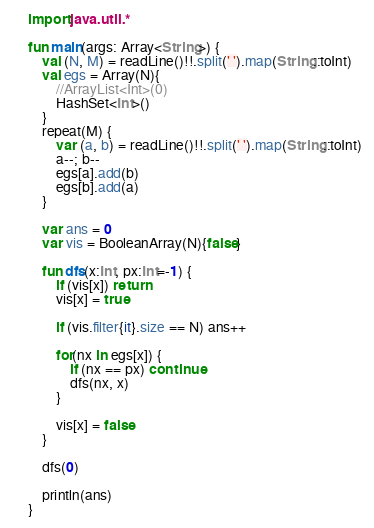Convert code to text. <code><loc_0><loc_0><loc_500><loc_500><_Kotlin_>import java.util.*

fun main(args: Array<String>) {
    val (N, M) = readLine()!!.split(' ').map(String::toInt)
    val egs = Array(N){
        //ArrayList<Int>(0)
        HashSet<Int>()
    }
    repeat(M) {
        var (a, b) = readLine()!!.split(' ').map(String::toInt)
        a--; b--
        egs[a].add(b)
        egs[b].add(a)
    }

    var ans = 0
    var vis = BooleanArray(N){false}

    fun dfs(x:Int, px:Int=-1) {
        if (vis[x]) return
        vis[x] = true

        if (vis.filter{it}.size == N) ans++

        for(nx in egs[x]) {
            if (nx == px) continue
            dfs(nx, x)
        }

        vis[x] = false
    }

    dfs(0)

    println(ans)
}
</code> 